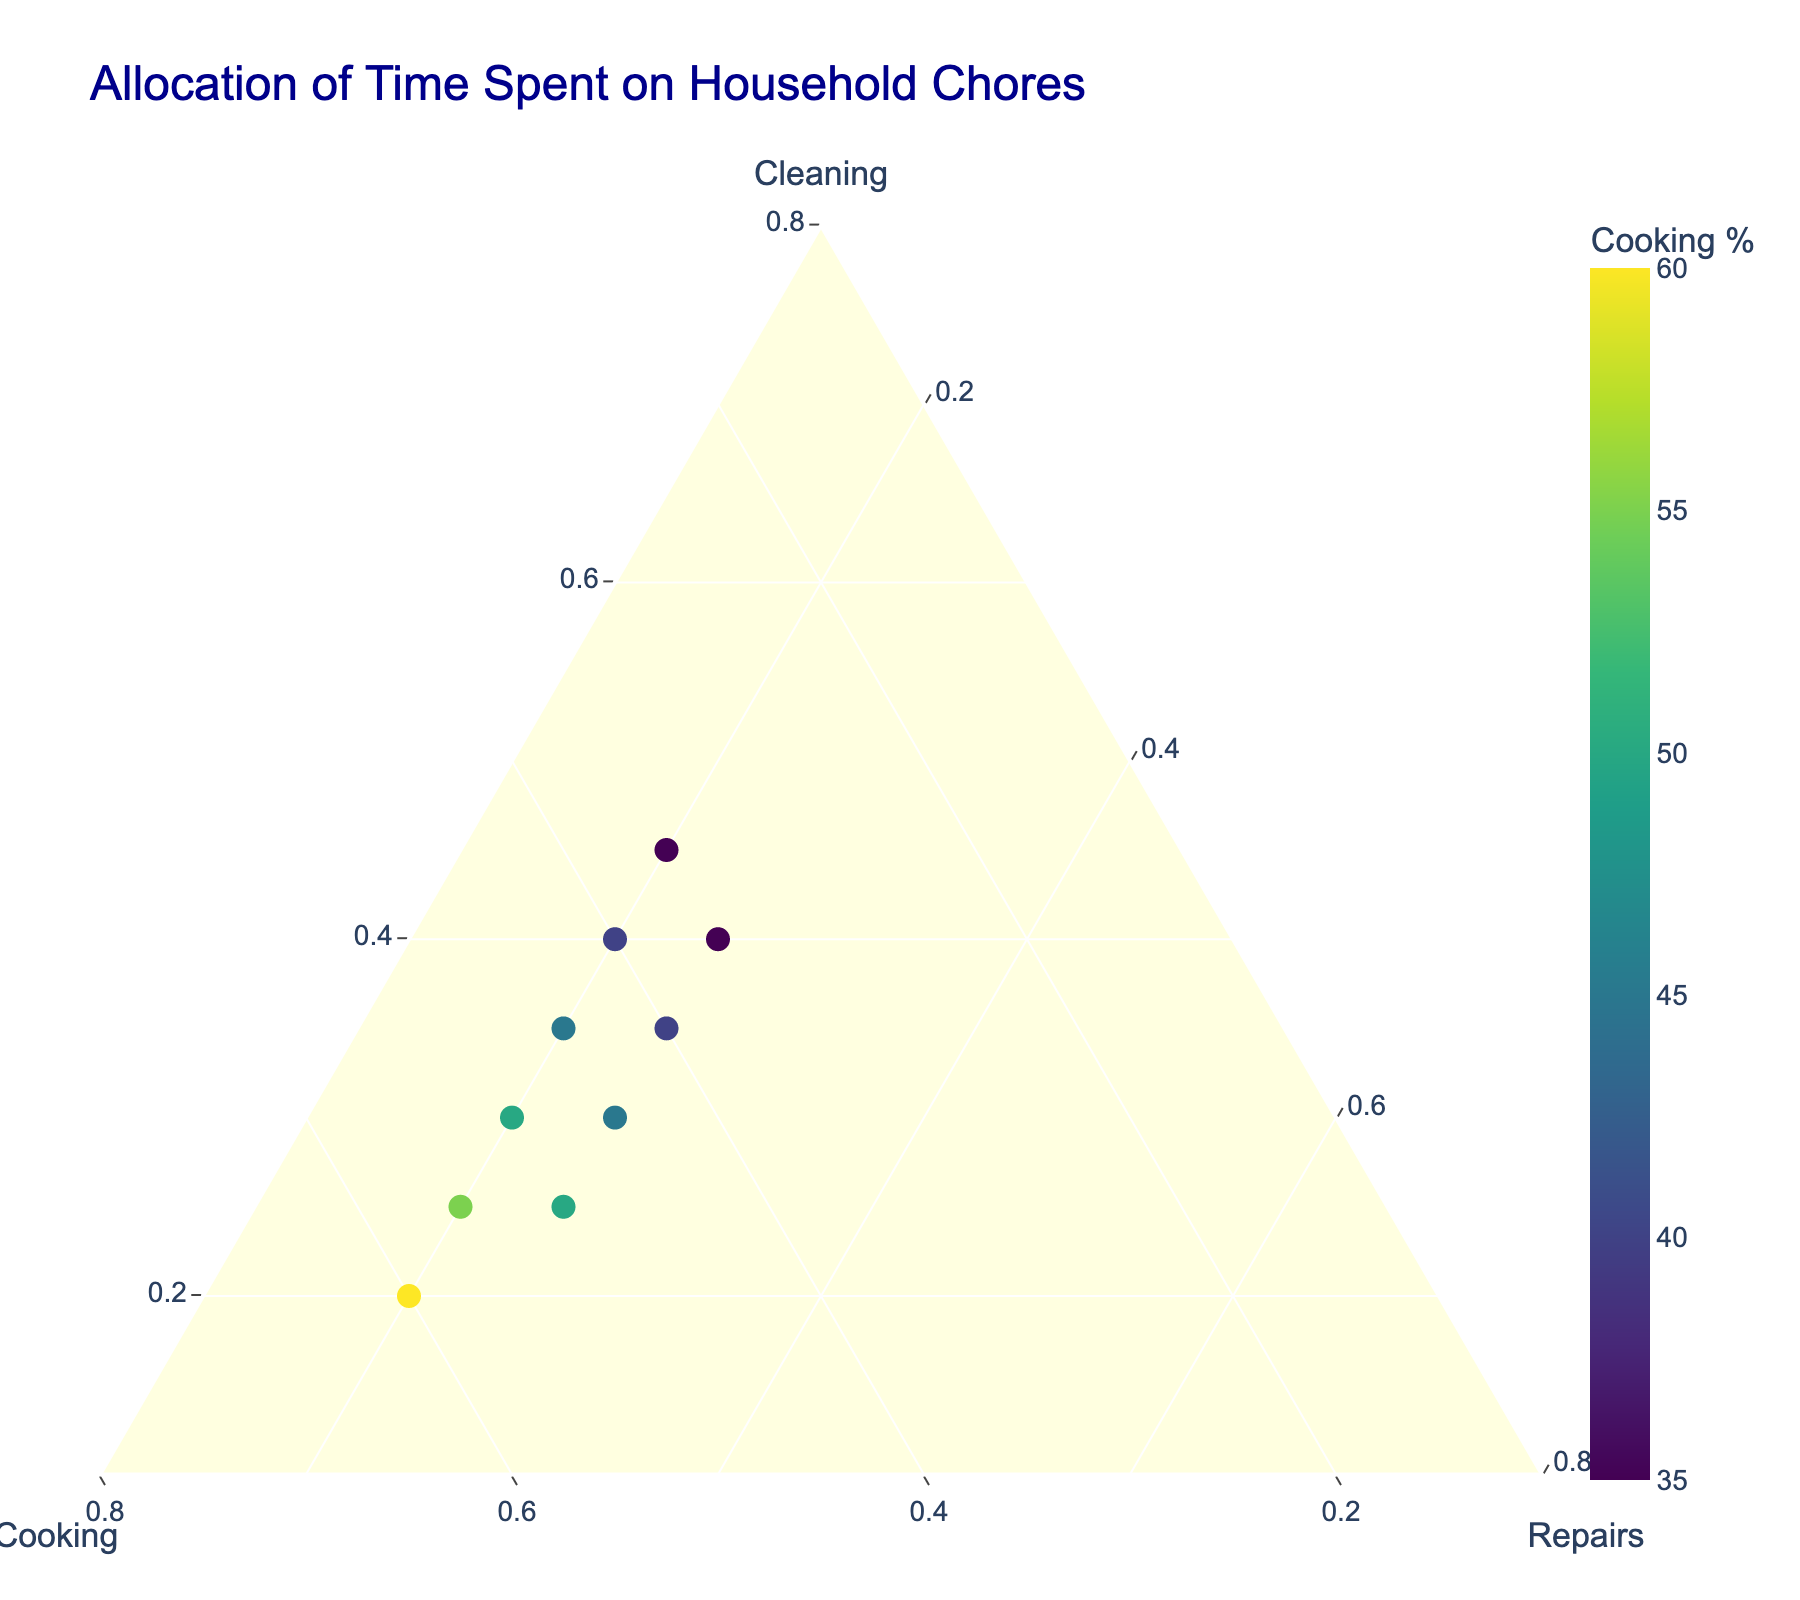What is the title of the figure? Look at the top part of the figure to find the title.
Answer: Allocation of Time Spent on Household Chores What is the color that indicates the highest percentage of cooking? Refer to the color bar legend and note which color is at the top end of the scale.
Answer: Dark yellow How many data points are plotted in the figure? Count the number of markers present in the ternary plot.
Answer: 10 Which chore has the most evenly distributed time allocations among the different homes, based on the axis labels? Assess the variability and spread of the markers along each of the three axes.
Answer: Repairs What is the range of Cleaning percentages? Identify the minimum and maximum points of Cleaning values among the data points.
Answer: 20% - 45% Which chores' percentage seems to be frequently equal across different households? Look for common values that appear in the data points for all chores.
Answer: 25% Repairs What's the point with the highest percentage of Cleaning? Check the values at each marker to determine the one with the highest Cleaning percentage.
Answer: Cleaning: 45%, Cooking: 35%, Repairs: 20% How does the percentage of Cleaning compare between the first and the last data points? Compare the Cleaning percentages of the first and the last markers.
Answer: The first is 30% and the last is 45%, 45% is greater Is there a point where the allocation percentages for Cleaning and Repairs are equal? Check each data point to see if any has equal values for Cleaning and Repairs.
Answer: No 